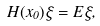Convert formula to latex. <formula><loc_0><loc_0><loc_500><loc_500>H ( x _ { 0 } ) \xi = E \xi ,</formula> 